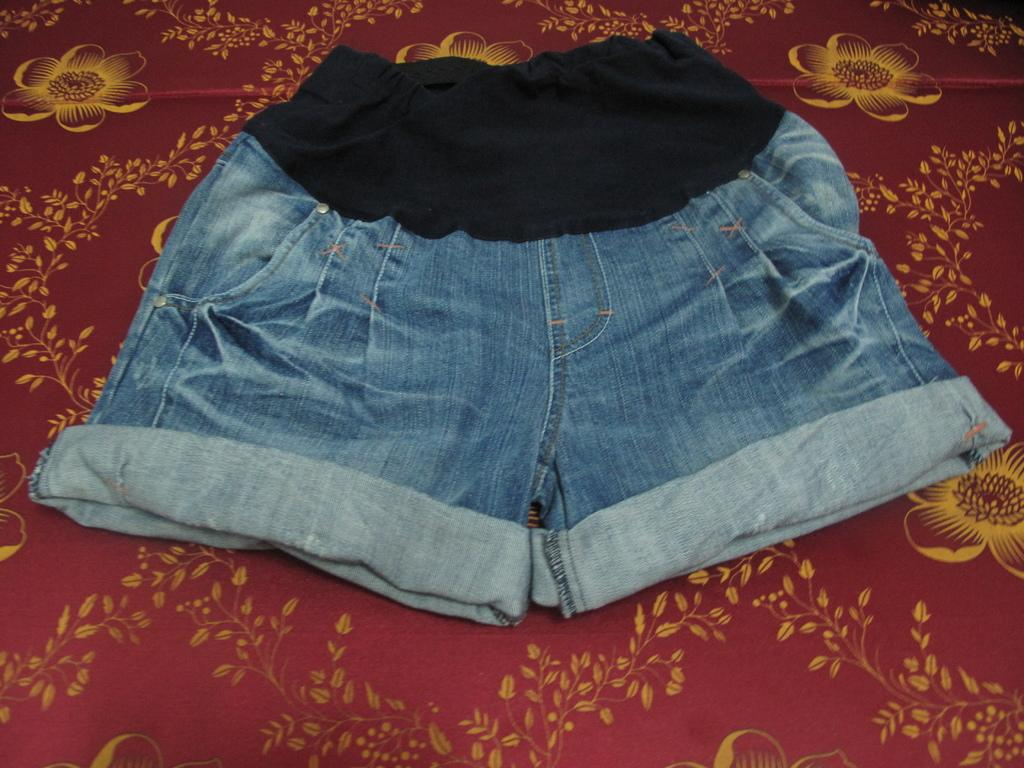What type of clothing item is in the image? There is a denim short in the image. Can you describe the position or state of the denim short in the image? The denim short is on a surface. What part of the giant's body does the denim short belong to in the image? There are no giants present in the image, and therefore no such association can be made. 